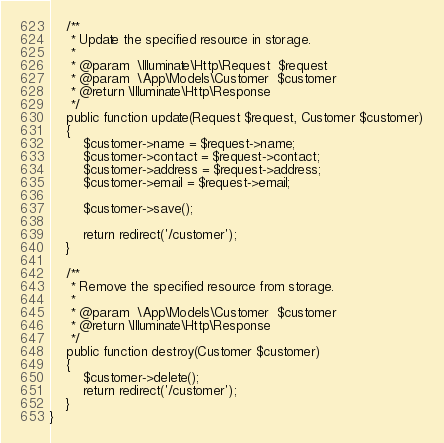Convert code to text. <code><loc_0><loc_0><loc_500><loc_500><_PHP_>    /**
     * Update the specified resource in storage.
     *
     * @param  \Illuminate\Http\Request  $request
     * @param  \App\Models\Customer  $customer
     * @return \Illuminate\Http\Response
     */
    public function update(Request $request, Customer $customer)
    {
        $customer->name = $request->name;
        $customer->contact = $request->contact;
        $customer->address = $request->address;
        $customer->email = $request->email;

        $customer->save();

        return redirect('/customer');
    }

    /**
     * Remove the specified resource from storage.
     *
     * @param  \App\Models\Customer  $customer
     * @return \Illuminate\Http\Response
     */
    public function destroy(Customer $customer)
    {
        $customer->delete();
        return redirect('/customer');
    }
}
</code> 